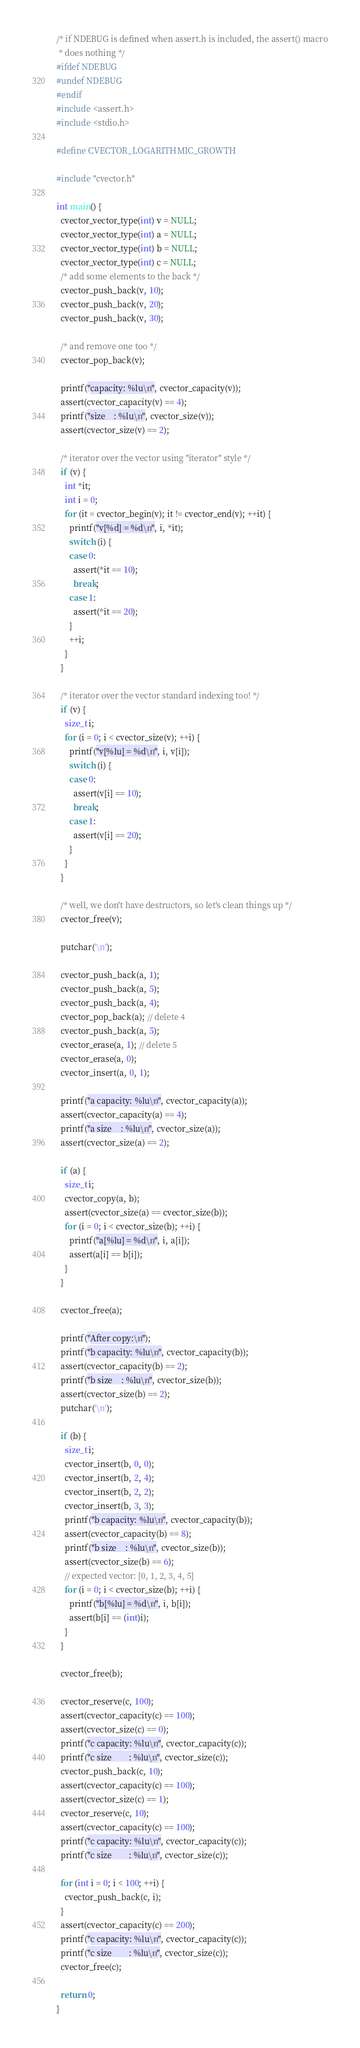Convert code to text. <code><loc_0><loc_0><loc_500><loc_500><_C_>/* if NDEBUG is defined when assert.h is included, the assert() macro
 * does nothing */
#ifdef NDEBUG
#undef NDEBUG
#endif
#include <assert.h>
#include <stdio.h>

#define CVECTOR_LOGARITHMIC_GROWTH

#include "cvector.h"

int main() {
  cvector_vector_type(int) v = NULL;
  cvector_vector_type(int) a = NULL;
  cvector_vector_type(int) b = NULL;
  cvector_vector_type(int) c = NULL;
  /* add some elements to the back */
  cvector_push_back(v, 10);
  cvector_push_back(v, 20);
  cvector_push_back(v, 30);

  /* and remove one too */
  cvector_pop_back(v);

  printf("capacity: %lu\n", cvector_capacity(v));
  assert(cvector_capacity(v) == 4);
  printf("size    : %lu\n", cvector_size(v));
  assert(cvector_size(v) == 2);

  /* iterator over the vector using "iterator" style */
  if (v) {
    int *it;
    int i = 0;
    for (it = cvector_begin(v); it != cvector_end(v); ++it) {
      printf("v[%d] = %d\n", i, *it);
      switch (i) {
      case 0:
        assert(*it == 10);
        break;
      case 1:
        assert(*it == 20);
      }
      ++i;
    }
  }

  /* iterator over the vector standard indexing too! */
  if (v) {
    size_t i;
    for (i = 0; i < cvector_size(v); ++i) {
      printf("v[%lu] = %d\n", i, v[i]);
      switch (i) {
      case 0:
        assert(v[i] == 10);
        break;
      case 1:
        assert(v[i] == 20);
      }
    }
  }

  /* well, we don't have destructors, so let's clean things up */
  cvector_free(v);

  putchar('\n');

  cvector_push_back(a, 1);
  cvector_push_back(a, 5);
  cvector_push_back(a, 4);
  cvector_pop_back(a); // delete 4
  cvector_push_back(a, 5);
  cvector_erase(a, 1); // delete 5
  cvector_erase(a, 0);
  cvector_insert(a, 0, 1);

  printf("a capacity: %lu\n", cvector_capacity(a));
  assert(cvector_capacity(a) == 4);
  printf("a size    : %lu\n", cvector_size(a));
  assert(cvector_size(a) == 2);

  if (a) {
    size_t i;
    cvector_copy(a, b);
    assert(cvector_size(a) == cvector_size(b));
    for (i = 0; i < cvector_size(b); ++i) {
      printf("a[%lu] = %d\n", i, a[i]);
      assert(a[i] == b[i]);
    }
  }

  cvector_free(a);

  printf("After copy:\n");
  printf("b capacity: %lu\n", cvector_capacity(b));
  assert(cvector_capacity(b) == 2);
  printf("b size    : %lu\n", cvector_size(b));
  assert(cvector_size(b) == 2);
  putchar('\n');

  if (b) {
    size_t i;
    cvector_insert(b, 0, 0);
    cvector_insert(b, 2, 4);
    cvector_insert(b, 2, 2);
    cvector_insert(b, 3, 3);
    printf("b capacity: %lu\n", cvector_capacity(b));
    assert(cvector_capacity(b) == 8);
    printf("b size    : %lu\n", cvector_size(b));
    assert(cvector_size(b) == 6);
    // expected vector: [0, 1, 2, 3, 4, 5]
    for (i = 0; i < cvector_size(b); ++i) {
      printf("b[%lu] = %d\n", i, b[i]);
      assert(b[i] == (int)i);
    }
  }

  cvector_free(b);

  cvector_reserve(c, 100);
  assert(cvector_capacity(c) == 100);
  assert(cvector_size(c) == 0);
  printf("c capacity: %lu\n", cvector_capacity(c));
  printf("c size        : %lu\n", cvector_size(c));
  cvector_push_back(c, 10);
  assert(cvector_capacity(c) == 100);
  assert(cvector_size(c) == 1);
  cvector_reserve(c, 10);
  assert(cvector_capacity(c) == 100);
  printf("c capacity: %lu\n", cvector_capacity(c));
  printf("c size        : %lu\n", cvector_size(c));

  for (int i = 0; i < 100; ++i) {
    cvector_push_back(c, i);
  }
  assert(cvector_capacity(c) == 200);
  printf("c capacity: %lu\n", cvector_capacity(c));
  printf("c size        : %lu\n", cvector_size(c));
  cvector_free(c);

  return 0;
}
</code> 